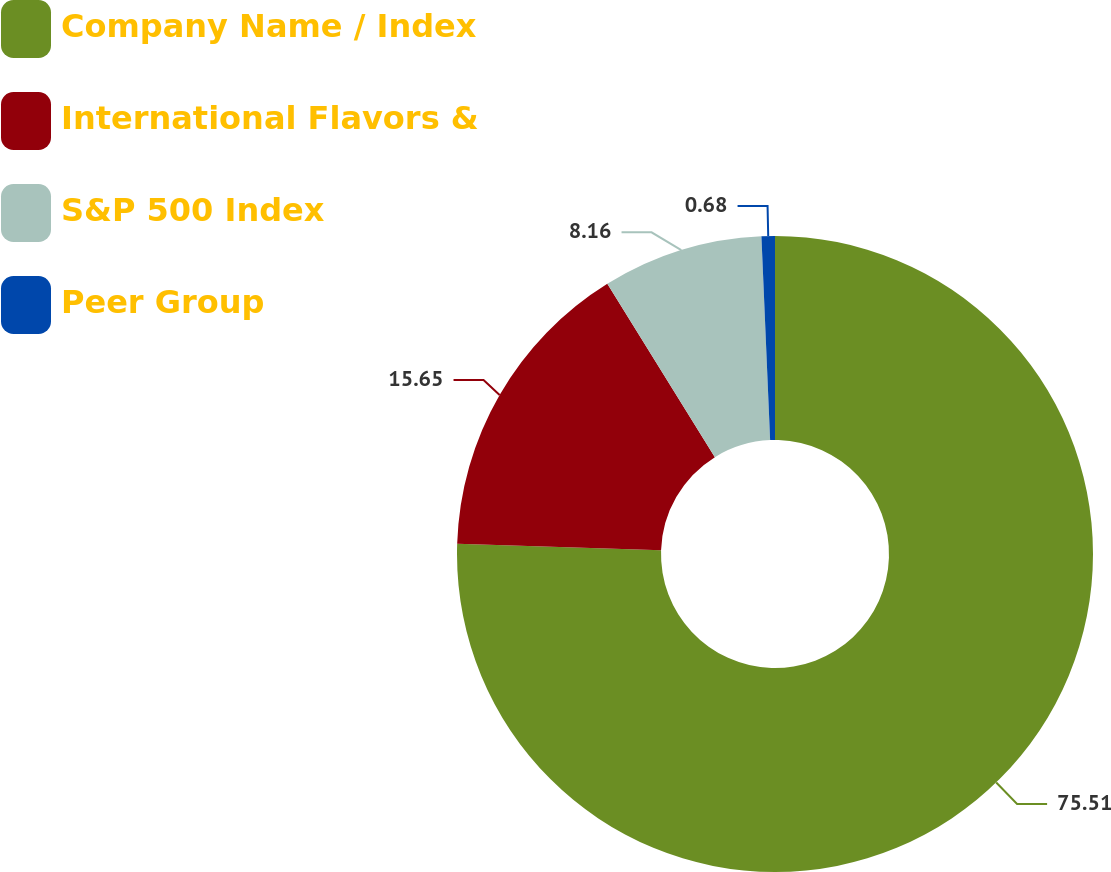Convert chart to OTSL. <chart><loc_0><loc_0><loc_500><loc_500><pie_chart><fcel>Company Name / Index<fcel>International Flavors &<fcel>S&P 500 Index<fcel>Peer Group<nl><fcel>75.51%<fcel>15.65%<fcel>8.16%<fcel>0.68%<nl></chart> 